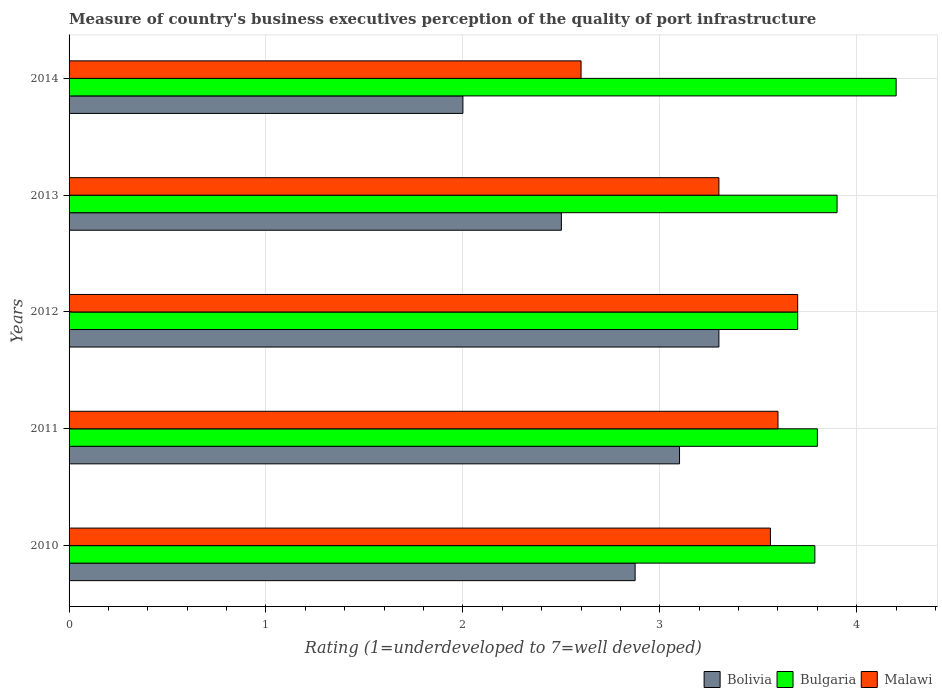How many different coloured bars are there?
Give a very brief answer. 3. Are the number of bars per tick equal to the number of legend labels?
Your answer should be very brief. Yes. How many bars are there on the 4th tick from the bottom?
Your answer should be very brief. 3. What is the label of the 1st group of bars from the top?
Your answer should be compact. 2014. What is the ratings of the quality of port infrastructure in Malawi in 2013?
Offer a terse response. 3.3. Across all years, what is the maximum ratings of the quality of port infrastructure in Bolivia?
Your response must be concise. 3.3. Across all years, what is the minimum ratings of the quality of port infrastructure in Bulgaria?
Your response must be concise. 3.7. In which year was the ratings of the quality of port infrastructure in Bolivia maximum?
Your answer should be compact. 2012. What is the total ratings of the quality of port infrastructure in Malawi in the graph?
Offer a terse response. 16.76. What is the difference between the ratings of the quality of port infrastructure in Bulgaria in 2011 and that in 2014?
Provide a short and direct response. -0.4. What is the difference between the ratings of the quality of port infrastructure in Bolivia in 2014 and the ratings of the quality of port infrastructure in Malawi in 2012?
Offer a terse response. -1.7. What is the average ratings of the quality of port infrastructure in Bolivia per year?
Your response must be concise. 2.75. In the year 2011, what is the difference between the ratings of the quality of port infrastructure in Bulgaria and ratings of the quality of port infrastructure in Malawi?
Offer a very short reply. 0.2. In how many years, is the ratings of the quality of port infrastructure in Bolivia greater than 4.2 ?
Offer a very short reply. 0. What is the ratio of the ratings of the quality of port infrastructure in Malawi in 2011 to that in 2012?
Your answer should be very brief. 0.97. What is the difference between the highest and the second highest ratings of the quality of port infrastructure in Bolivia?
Give a very brief answer. 0.2. What is the difference between the highest and the lowest ratings of the quality of port infrastructure in Bolivia?
Offer a terse response. 1.3. Is the sum of the ratings of the quality of port infrastructure in Bulgaria in 2011 and 2014 greater than the maximum ratings of the quality of port infrastructure in Malawi across all years?
Provide a succinct answer. Yes. What does the 3rd bar from the bottom in 2014 represents?
Provide a short and direct response. Malawi. Is it the case that in every year, the sum of the ratings of the quality of port infrastructure in Malawi and ratings of the quality of port infrastructure in Bolivia is greater than the ratings of the quality of port infrastructure in Bulgaria?
Offer a terse response. Yes. How many bars are there?
Your answer should be very brief. 15. How many years are there in the graph?
Provide a succinct answer. 5. Are the values on the major ticks of X-axis written in scientific E-notation?
Keep it short and to the point. No. Does the graph contain grids?
Ensure brevity in your answer.  Yes. How are the legend labels stacked?
Offer a very short reply. Horizontal. What is the title of the graph?
Your answer should be compact. Measure of country's business executives perception of the quality of port infrastructure. Does "Mauritania" appear as one of the legend labels in the graph?
Ensure brevity in your answer.  No. What is the label or title of the X-axis?
Ensure brevity in your answer.  Rating (1=underdeveloped to 7=well developed). What is the label or title of the Y-axis?
Offer a terse response. Years. What is the Rating (1=underdeveloped to 7=well developed) in Bolivia in 2010?
Provide a succinct answer. 2.87. What is the Rating (1=underdeveloped to 7=well developed) of Bulgaria in 2010?
Your response must be concise. 3.79. What is the Rating (1=underdeveloped to 7=well developed) of Malawi in 2010?
Make the answer very short. 3.56. What is the Rating (1=underdeveloped to 7=well developed) of Bulgaria in 2011?
Offer a terse response. 3.8. What is the Rating (1=underdeveloped to 7=well developed) in Bulgaria in 2012?
Your answer should be very brief. 3.7. What is the Rating (1=underdeveloped to 7=well developed) of Malawi in 2013?
Provide a succinct answer. 3.3. What is the Rating (1=underdeveloped to 7=well developed) in Bolivia in 2014?
Make the answer very short. 2. What is the Rating (1=underdeveloped to 7=well developed) of Malawi in 2014?
Provide a succinct answer. 2.6. Across all years, what is the maximum Rating (1=underdeveloped to 7=well developed) in Bolivia?
Give a very brief answer. 3.3. Across all years, what is the maximum Rating (1=underdeveloped to 7=well developed) of Bulgaria?
Your answer should be very brief. 4.2. Across all years, what is the maximum Rating (1=underdeveloped to 7=well developed) in Malawi?
Provide a succinct answer. 3.7. Across all years, what is the minimum Rating (1=underdeveloped to 7=well developed) of Bolivia?
Make the answer very short. 2. Across all years, what is the minimum Rating (1=underdeveloped to 7=well developed) in Bulgaria?
Your answer should be very brief. 3.7. Across all years, what is the minimum Rating (1=underdeveloped to 7=well developed) of Malawi?
Your response must be concise. 2.6. What is the total Rating (1=underdeveloped to 7=well developed) in Bolivia in the graph?
Give a very brief answer. 13.77. What is the total Rating (1=underdeveloped to 7=well developed) in Bulgaria in the graph?
Make the answer very short. 19.39. What is the total Rating (1=underdeveloped to 7=well developed) of Malawi in the graph?
Your answer should be very brief. 16.76. What is the difference between the Rating (1=underdeveloped to 7=well developed) in Bolivia in 2010 and that in 2011?
Offer a very short reply. -0.23. What is the difference between the Rating (1=underdeveloped to 7=well developed) in Bulgaria in 2010 and that in 2011?
Give a very brief answer. -0.01. What is the difference between the Rating (1=underdeveloped to 7=well developed) in Malawi in 2010 and that in 2011?
Keep it short and to the point. -0.04. What is the difference between the Rating (1=underdeveloped to 7=well developed) of Bolivia in 2010 and that in 2012?
Give a very brief answer. -0.43. What is the difference between the Rating (1=underdeveloped to 7=well developed) of Bulgaria in 2010 and that in 2012?
Your answer should be very brief. 0.09. What is the difference between the Rating (1=underdeveloped to 7=well developed) of Malawi in 2010 and that in 2012?
Provide a short and direct response. -0.14. What is the difference between the Rating (1=underdeveloped to 7=well developed) in Bolivia in 2010 and that in 2013?
Your answer should be very brief. 0.37. What is the difference between the Rating (1=underdeveloped to 7=well developed) of Bulgaria in 2010 and that in 2013?
Offer a terse response. -0.11. What is the difference between the Rating (1=underdeveloped to 7=well developed) in Malawi in 2010 and that in 2013?
Make the answer very short. 0.26. What is the difference between the Rating (1=underdeveloped to 7=well developed) in Bolivia in 2010 and that in 2014?
Provide a succinct answer. 0.87. What is the difference between the Rating (1=underdeveloped to 7=well developed) in Bulgaria in 2010 and that in 2014?
Keep it short and to the point. -0.41. What is the difference between the Rating (1=underdeveloped to 7=well developed) of Malawi in 2010 and that in 2014?
Your answer should be very brief. 0.96. What is the difference between the Rating (1=underdeveloped to 7=well developed) in Bolivia in 2011 and that in 2013?
Keep it short and to the point. 0.6. What is the difference between the Rating (1=underdeveloped to 7=well developed) of Bulgaria in 2011 and that in 2013?
Your answer should be compact. -0.1. What is the difference between the Rating (1=underdeveloped to 7=well developed) of Bulgaria in 2011 and that in 2014?
Your answer should be compact. -0.4. What is the difference between the Rating (1=underdeveloped to 7=well developed) of Bolivia in 2012 and that in 2014?
Your response must be concise. 1.3. What is the difference between the Rating (1=underdeveloped to 7=well developed) in Bulgaria in 2012 and that in 2014?
Your answer should be compact. -0.5. What is the difference between the Rating (1=underdeveloped to 7=well developed) in Malawi in 2012 and that in 2014?
Keep it short and to the point. 1.1. What is the difference between the Rating (1=underdeveloped to 7=well developed) of Bolivia in 2013 and that in 2014?
Your answer should be very brief. 0.5. What is the difference between the Rating (1=underdeveloped to 7=well developed) in Bulgaria in 2013 and that in 2014?
Your answer should be compact. -0.3. What is the difference between the Rating (1=underdeveloped to 7=well developed) of Malawi in 2013 and that in 2014?
Your response must be concise. 0.7. What is the difference between the Rating (1=underdeveloped to 7=well developed) of Bolivia in 2010 and the Rating (1=underdeveloped to 7=well developed) of Bulgaria in 2011?
Your response must be concise. -0.93. What is the difference between the Rating (1=underdeveloped to 7=well developed) in Bolivia in 2010 and the Rating (1=underdeveloped to 7=well developed) in Malawi in 2011?
Give a very brief answer. -0.73. What is the difference between the Rating (1=underdeveloped to 7=well developed) of Bulgaria in 2010 and the Rating (1=underdeveloped to 7=well developed) of Malawi in 2011?
Offer a very short reply. 0.19. What is the difference between the Rating (1=underdeveloped to 7=well developed) in Bolivia in 2010 and the Rating (1=underdeveloped to 7=well developed) in Bulgaria in 2012?
Offer a very short reply. -0.83. What is the difference between the Rating (1=underdeveloped to 7=well developed) in Bolivia in 2010 and the Rating (1=underdeveloped to 7=well developed) in Malawi in 2012?
Offer a terse response. -0.83. What is the difference between the Rating (1=underdeveloped to 7=well developed) of Bulgaria in 2010 and the Rating (1=underdeveloped to 7=well developed) of Malawi in 2012?
Make the answer very short. 0.09. What is the difference between the Rating (1=underdeveloped to 7=well developed) in Bolivia in 2010 and the Rating (1=underdeveloped to 7=well developed) in Bulgaria in 2013?
Make the answer very short. -1.03. What is the difference between the Rating (1=underdeveloped to 7=well developed) in Bolivia in 2010 and the Rating (1=underdeveloped to 7=well developed) in Malawi in 2013?
Your answer should be compact. -0.43. What is the difference between the Rating (1=underdeveloped to 7=well developed) in Bulgaria in 2010 and the Rating (1=underdeveloped to 7=well developed) in Malawi in 2013?
Your answer should be compact. 0.49. What is the difference between the Rating (1=underdeveloped to 7=well developed) of Bolivia in 2010 and the Rating (1=underdeveloped to 7=well developed) of Bulgaria in 2014?
Keep it short and to the point. -1.33. What is the difference between the Rating (1=underdeveloped to 7=well developed) of Bolivia in 2010 and the Rating (1=underdeveloped to 7=well developed) of Malawi in 2014?
Your response must be concise. 0.27. What is the difference between the Rating (1=underdeveloped to 7=well developed) of Bulgaria in 2010 and the Rating (1=underdeveloped to 7=well developed) of Malawi in 2014?
Keep it short and to the point. 1.19. What is the difference between the Rating (1=underdeveloped to 7=well developed) of Bolivia in 2011 and the Rating (1=underdeveloped to 7=well developed) of Bulgaria in 2012?
Offer a very short reply. -0.6. What is the difference between the Rating (1=underdeveloped to 7=well developed) in Bolivia in 2011 and the Rating (1=underdeveloped to 7=well developed) in Malawi in 2012?
Offer a terse response. -0.6. What is the difference between the Rating (1=underdeveloped to 7=well developed) of Bulgaria in 2011 and the Rating (1=underdeveloped to 7=well developed) of Malawi in 2012?
Keep it short and to the point. 0.1. What is the difference between the Rating (1=underdeveloped to 7=well developed) in Bolivia in 2011 and the Rating (1=underdeveloped to 7=well developed) in Malawi in 2014?
Keep it short and to the point. 0.5. What is the difference between the Rating (1=underdeveloped to 7=well developed) in Bulgaria in 2011 and the Rating (1=underdeveloped to 7=well developed) in Malawi in 2014?
Offer a terse response. 1.2. What is the difference between the Rating (1=underdeveloped to 7=well developed) in Bolivia in 2012 and the Rating (1=underdeveloped to 7=well developed) in Bulgaria in 2013?
Your response must be concise. -0.6. What is the difference between the Rating (1=underdeveloped to 7=well developed) in Bolivia in 2012 and the Rating (1=underdeveloped to 7=well developed) in Malawi in 2013?
Your response must be concise. 0. What is the difference between the Rating (1=underdeveloped to 7=well developed) of Bolivia in 2012 and the Rating (1=underdeveloped to 7=well developed) of Bulgaria in 2014?
Ensure brevity in your answer.  -0.9. What is the average Rating (1=underdeveloped to 7=well developed) in Bolivia per year?
Your response must be concise. 2.75. What is the average Rating (1=underdeveloped to 7=well developed) in Bulgaria per year?
Offer a terse response. 3.88. What is the average Rating (1=underdeveloped to 7=well developed) in Malawi per year?
Ensure brevity in your answer.  3.35. In the year 2010, what is the difference between the Rating (1=underdeveloped to 7=well developed) of Bolivia and Rating (1=underdeveloped to 7=well developed) of Bulgaria?
Provide a succinct answer. -0.91. In the year 2010, what is the difference between the Rating (1=underdeveloped to 7=well developed) in Bolivia and Rating (1=underdeveloped to 7=well developed) in Malawi?
Your answer should be compact. -0.69. In the year 2010, what is the difference between the Rating (1=underdeveloped to 7=well developed) in Bulgaria and Rating (1=underdeveloped to 7=well developed) in Malawi?
Give a very brief answer. 0.23. In the year 2011, what is the difference between the Rating (1=underdeveloped to 7=well developed) in Bolivia and Rating (1=underdeveloped to 7=well developed) in Bulgaria?
Your answer should be compact. -0.7. In the year 2011, what is the difference between the Rating (1=underdeveloped to 7=well developed) of Bolivia and Rating (1=underdeveloped to 7=well developed) of Malawi?
Offer a terse response. -0.5. In the year 2011, what is the difference between the Rating (1=underdeveloped to 7=well developed) of Bulgaria and Rating (1=underdeveloped to 7=well developed) of Malawi?
Give a very brief answer. 0.2. In the year 2012, what is the difference between the Rating (1=underdeveloped to 7=well developed) in Bolivia and Rating (1=underdeveloped to 7=well developed) in Bulgaria?
Offer a terse response. -0.4. In the year 2012, what is the difference between the Rating (1=underdeveloped to 7=well developed) of Bulgaria and Rating (1=underdeveloped to 7=well developed) of Malawi?
Ensure brevity in your answer.  0. In the year 2014, what is the difference between the Rating (1=underdeveloped to 7=well developed) of Bolivia and Rating (1=underdeveloped to 7=well developed) of Bulgaria?
Offer a terse response. -2.2. In the year 2014, what is the difference between the Rating (1=underdeveloped to 7=well developed) of Bolivia and Rating (1=underdeveloped to 7=well developed) of Malawi?
Provide a succinct answer. -0.6. In the year 2014, what is the difference between the Rating (1=underdeveloped to 7=well developed) of Bulgaria and Rating (1=underdeveloped to 7=well developed) of Malawi?
Keep it short and to the point. 1.6. What is the ratio of the Rating (1=underdeveloped to 7=well developed) of Bolivia in 2010 to that in 2011?
Your response must be concise. 0.93. What is the ratio of the Rating (1=underdeveloped to 7=well developed) in Malawi in 2010 to that in 2011?
Keep it short and to the point. 0.99. What is the ratio of the Rating (1=underdeveloped to 7=well developed) of Bolivia in 2010 to that in 2012?
Your response must be concise. 0.87. What is the ratio of the Rating (1=underdeveloped to 7=well developed) of Bulgaria in 2010 to that in 2012?
Provide a succinct answer. 1.02. What is the ratio of the Rating (1=underdeveloped to 7=well developed) of Malawi in 2010 to that in 2012?
Offer a terse response. 0.96. What is the ratio of the Rating (1=underdeveloped to 7=well developed) of Bolivia in 2010 to that in 2013?
Keep it short and to the point. 1.15. What is the ratio of the Rating (1=underdeveloped to 7=well developed) in Bulgaria in 2010 to that in 2013?
Your answer should be very brief. 0.97. What is the ratio of the Rating (1=underdeveloped to 7=well developed) of Malawi in 2010 to that in 2013?
Provide a short and direct response. 1.08. What is the ratio of the Rating (1=underdeveloped to 7=well developed) in Bolivia in 2010 to that in 2014?
Offer a terse response. 1.44. What is the ratio of the Rating (1=underdeveloped to 7=well developed) in Bulgaria in 2010 to that in 2014?
Your response must be concise. 0.9. What is the ratio of the Rating (1=underdeveloped to 7=well developed) of Malawi in 2010 to that in 2014?
Give a very brief answer. 1.37. What is the ratio of the Rating (1=underdeveloped to 7=well developed) in Bolivia in 2011 to that in 2012?
Your answer should be compact. 0.94. What is the ratio of the Rating (1=underdeveloped to 7=well developed) of Malawi in 2011 to that in 2012?
Your response must be concise. 0.97. What is the ratio of the Rating (1=underdeveloped to 7=well developed) in Bolivia in 2011 to that in 2013?
Your response must be concise. 1.24. What is the ratio of the Rating (1=underdeveloped to 7=well developed) in Bulgaria in 2011 to that in 2013?
Your answer should be compact. 0.97. What is the ratio of the Rating (1=underdeveloped to 7=well developed) in Bolivia in 2011 to that in 2014?
Keep it short and to the point. 1.55. What is the ratio of the Rating (1=underdeveloped to 7=well developed) of Bulgaria in 2011 to that in 2014?
Provide a short and direct response. 0.9. What is the ratio of the Rating (1=underdeveloped to 7=well developed) of Malawi in 2011 to that in 2014?
Provide a succinct answer. 1.38. What is the ratio of the Rating (1=underdeveloped to 7=well developed) in Bolivia in 2012 to that in 2013?
Offer a terse response. 1.32. What is the ratio of the Rating (1=underdeveloped to 7=well developed) of Bulgaria in 2012 to that in 2013?
Ensure brevity in your answer.  0.95. What is the ratio of the Rating (1=underdeveloped to 7=well developed) of Malawi in 2012 to that in 2013?
Offer a terse response. 1.12. What is the ratio of the Rating (1=underdeveloped to 7=well developed) in Bolivia in 2012 to that in 2014?
Offer a terse response. 1.65. What is the ratio of the Rating (1=underdeveloped to 7=well developed) of Bulgaria in 2012 to that in 2014?
Ensure brevity in your answer.  0.88. What is the ratio of the Rating (1=underdeveloped to 7=well developed) in Malawi in 2012 to that in 2014?
Provide a short and direct response. 1.42. What is the ratio of the Rating (1=underdeveloped to 7=well developed) of Bolivia in 2013 to that in 2014?
Keep it short and to the point. 1.25. What is the ratio of the Rating (1=underdeveloped to 7=well developed) of Bulgaria in 2013 to that in 2014?
Provide a short and direct response. 0.93. What is the ratio of the Rating (1=underdeveloped to 7=well developed) of Malawi in 2013 to that in 2014?
Your response must be concise. 1.27. What is the difference between the highest and the second highest Rating (1=underdeveloped to 7=well developed) of Bolivia?
Ensure brevity in your answer.  0.2. What is the difference between the highest and the lowest Rating (1=underdeveloped to 7=well developed) in Bolivia?
Offer a very short reply. 1.3. What is the difference between the highest and the lowest Rating (1=underdeveloped to 7=well developed) of Bulgaria?
Your response must be concise. 0.5. What is the difference between the highest and the lowest Rating (1=underdeveloped to 7=well developed) of Malawi?
Make the answer very short. 1.1. 